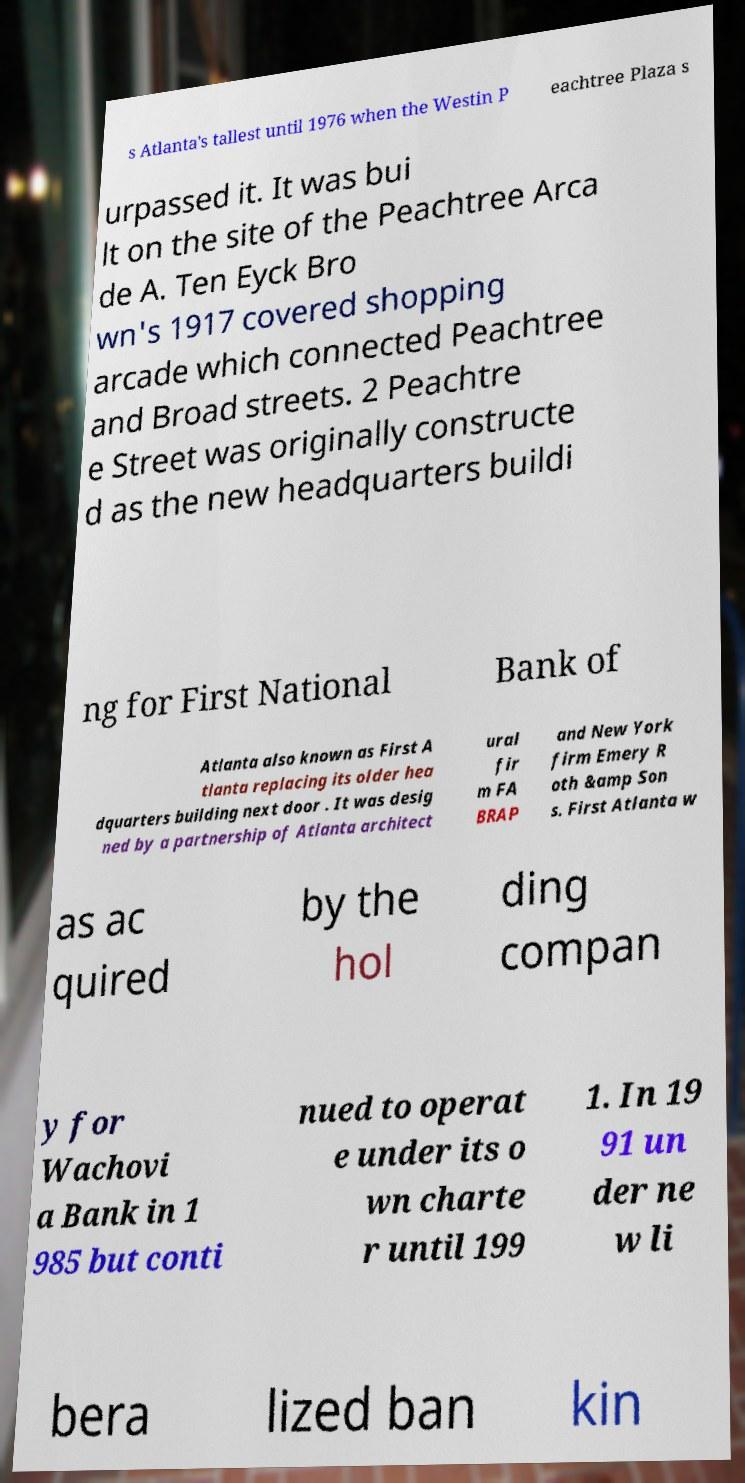There's text embedded in this image that I need extracted. Can you transcribe it verbatim? s Atlanta's tallest until 1976 when the Westin P eachtree Plaza s urpassed it. It was bui lt on the site of the Peachtree Arca de A. Ten Eyck Bro wn's 1917 covered shopping arcade which connected Peachtree and Broad streets. 2 Peachtre e Street was originally constructe d as the new headquarters buildi ng for First National Bank of Atlanta also known as First A tlanta replacing its older hea dquarters building next door . It was desig ned by a partnership of Atlanta architect ural fir m FA BRAP and New York firm Emery R oth &amp Son s. First Atlanta w as ac quired by the hol ding compan y for Wachovi a Bank in 1 985 but conti nued to operat e under its o wn charte r until 199 1. In 19 91 un der ne w li bera lized ban kin 